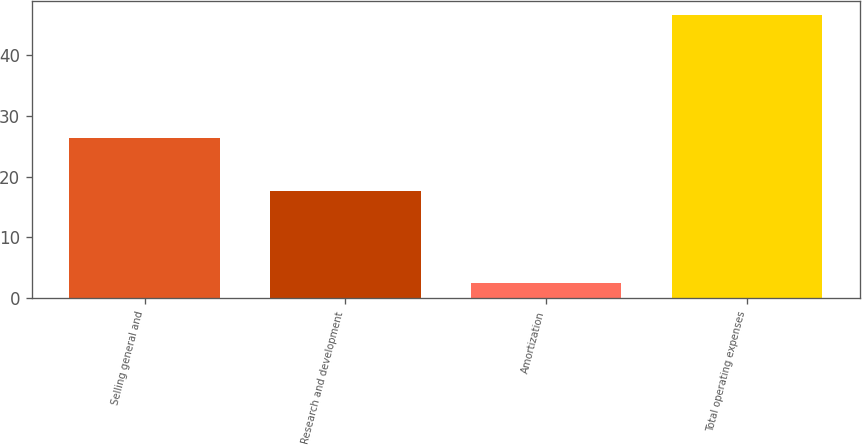Convert chart. <chart><loc_0><loc_0><loc_500><loc_500><bar_chart><fcel>Selling general and<fcel>Research and development<fcel>Amortization<fcel>Total operating expenses<nl><fcel>26.3<fcel>17.7<fcel>2.5<fcel>46.5<nl></chart> 